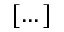<formula> <loc_0><loc_0><loc_500><loc_500>[ \dots ]</formula> 